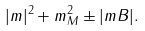<formula> <loc_0><loc_0><loc_500><loc_500>| m | ^ { 2 } + m _ { M } ^ { 2 } \pm | m B | .</formula> 